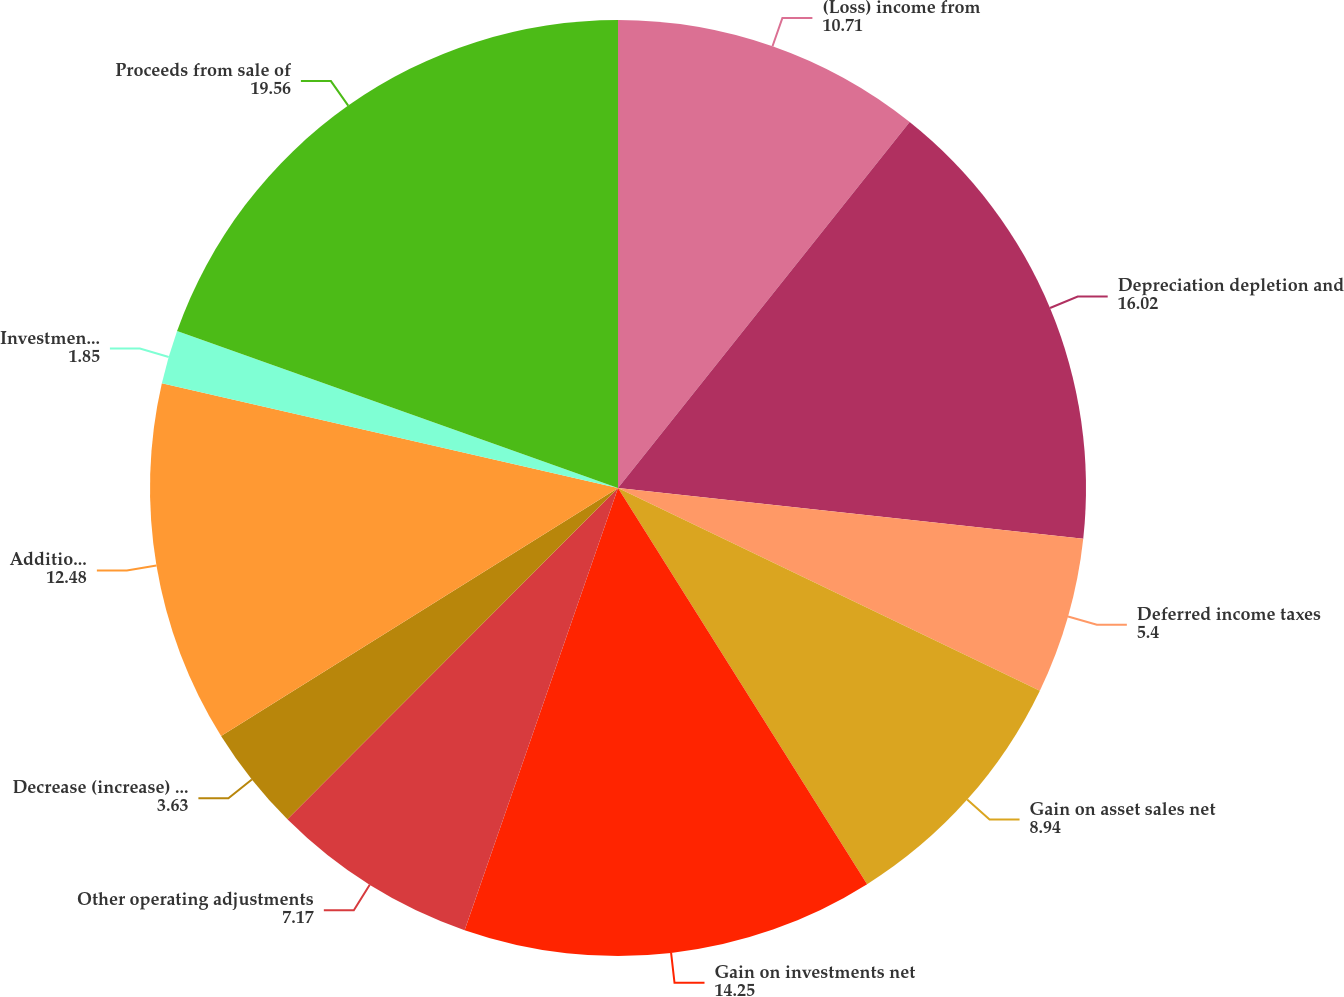Convert chart. <chart><loc_0><loc_0><loc_500><loc_500><pie_chart><fcel>(Loss) income from<fcel>Depreciation depletion and<fcel>Deferred income taxes<fcel>Gain on asset sales net<fcel>Gain on investments net<fcel>Other operating adjustments<fcel>Decrease (increase) in net<fcel>Additions to property plant<fcel>Investments in marketable<fcel>Proceeds from sale of<nl><fcel>10.71%<fcel>16.02%<fcel>5.4%<fcel>8.94%<fcel>14.25%<fcel>7.17%<fcel>3.63%<fcel>12.48%<fcel>1.85%<fcel>19.56%<nl></chart> 